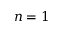<formula> <loc_0><loc_0><loc_500><loc_500>n = 1</formula> 